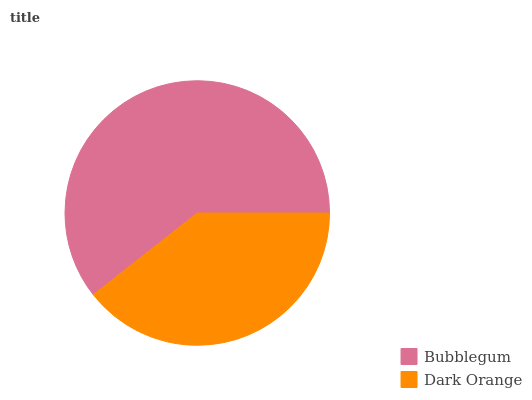Is Dark Orange the minimum?
Answer yes or no. Yes. Is Bubblegum the maximum?
Answer yes or no. Yes. Is Dark Orange the maximum?
Answer yes or no. No. Is Bubblegum greater than Dark Orange?
Answer yes or no. Yes. Is Dark Orange less than Bubblegum?
Answer yes or no. Yes. Is Dark Orange greater than Bubblegum?
Answer yes or no. No. Is Bubblegum less than Dark Orange?
Answer yes or no. No. Is Bubblegum the high median?
Answer yes or no. Yes. Is Dark Orange the low median?
Answer yes or no. Yes. Is Dark Orange the high median?
Answer yes or no. No. Is Bubblegum the low median?
Answer yes or no. No. 